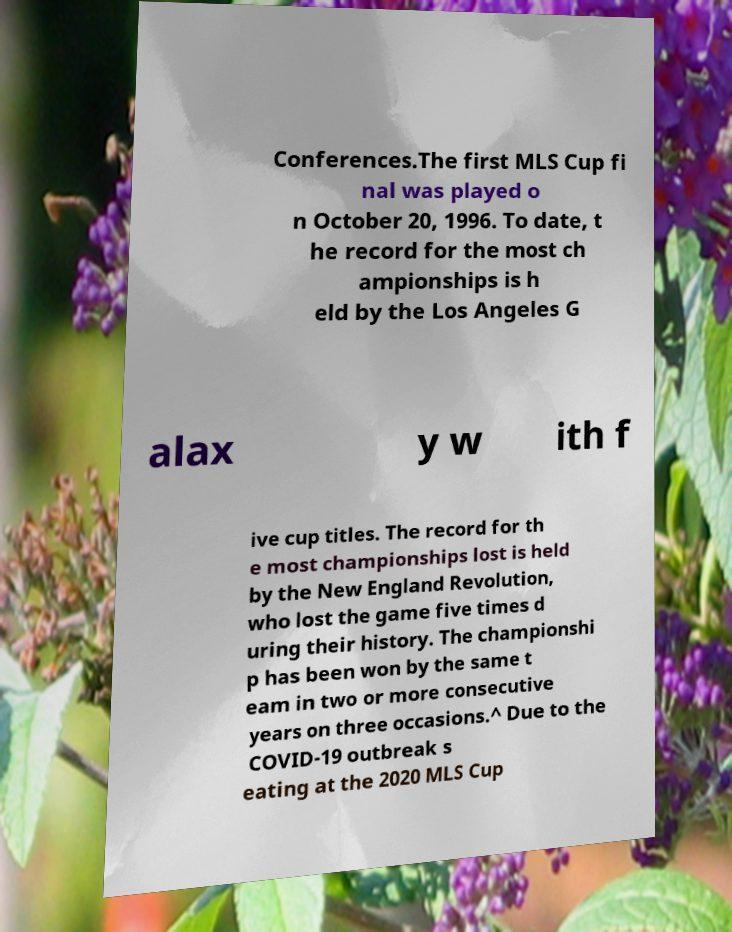Can you read and provide the text displayed in the image?This photo seems to have some interesting text. Can you extract and type it out for me? Conferences.The first MLS Cup fi nal was played o n October 20, 1996. To date, t he record for the most ch ampionships is h eld by the Los Angeles G alax y w ith f ive cup titles. The record for th e most championships lost is held by the New England Revolution, who lost the game five times d uring their history. The championshi p has been won by the same t eam in two or more consecutive years on three occasions.^ Due to the COVID-19 outbreak s eating at the 2020 MLS Cup 